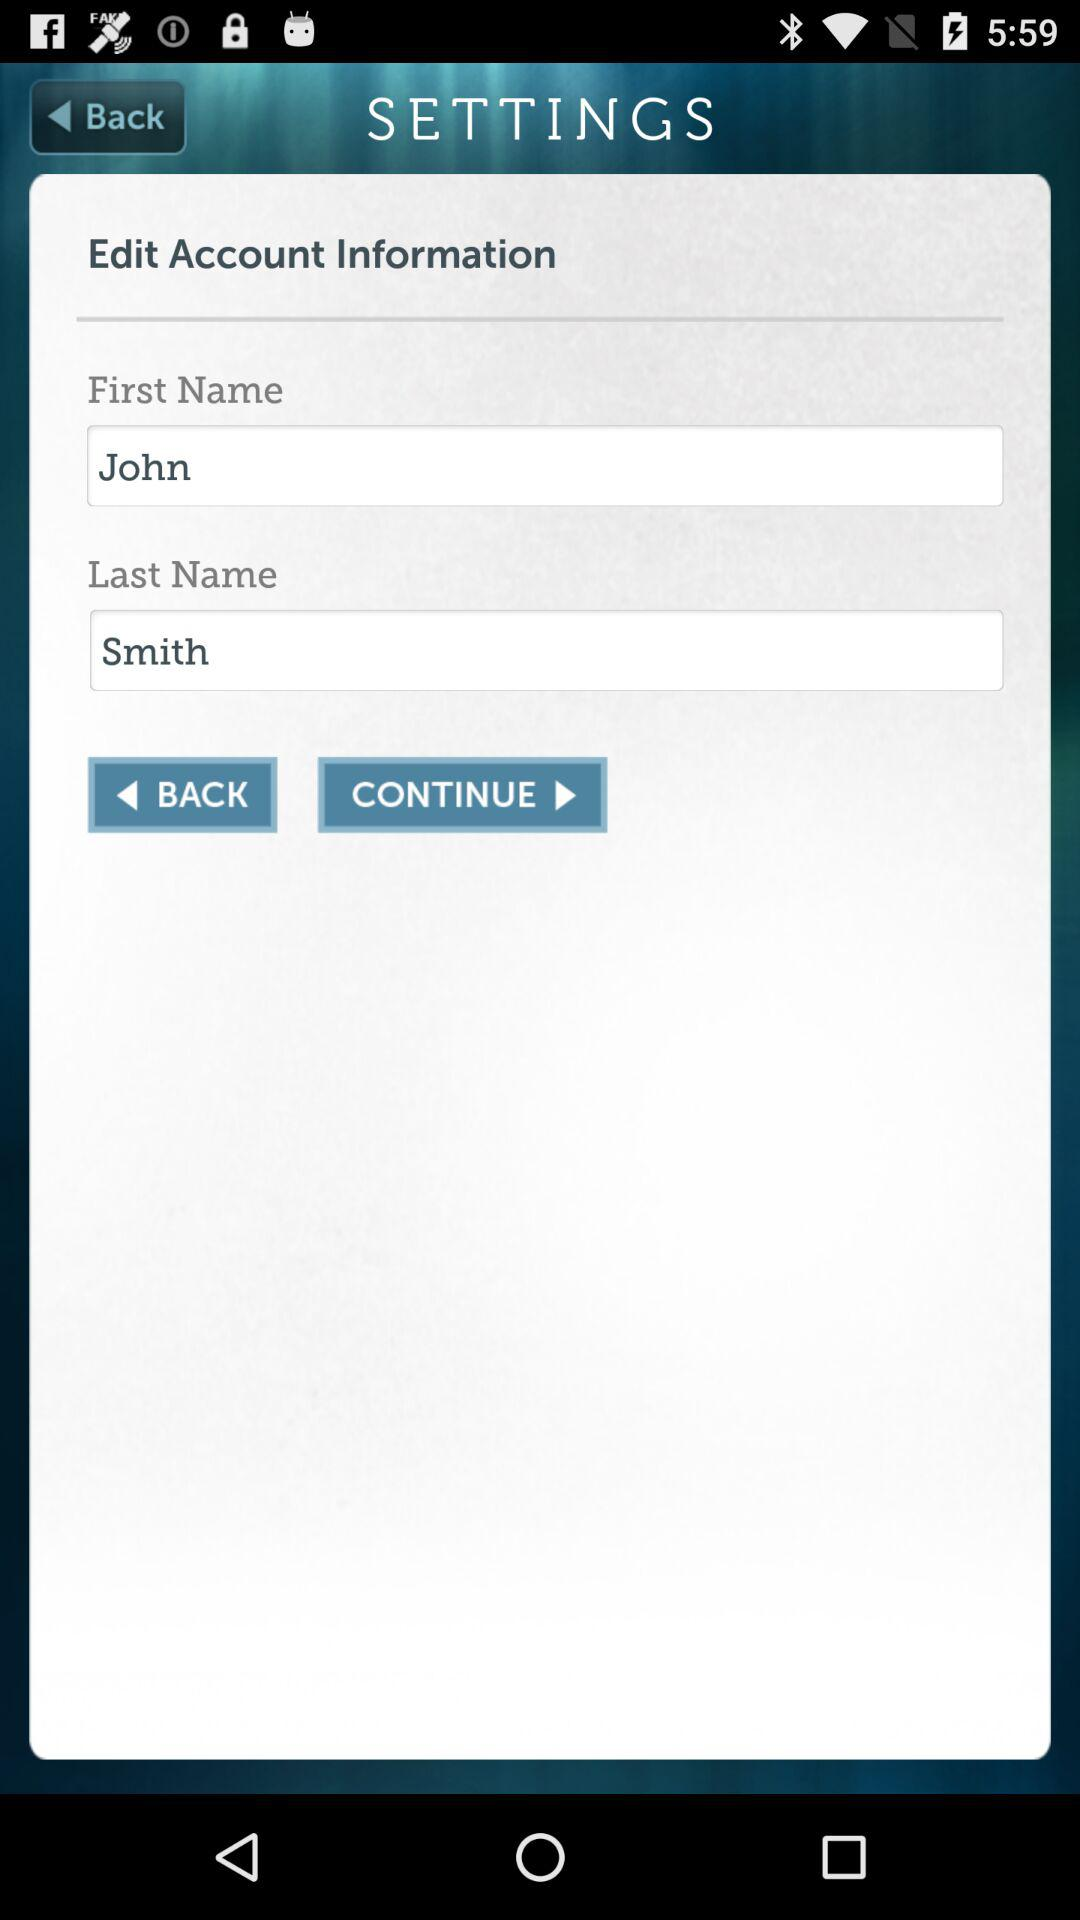What is the first name in the edit account information? The first name is John. 